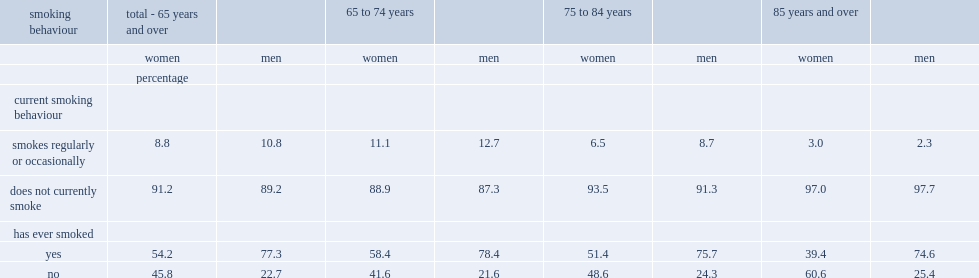What are the percentages of women and men aged 65 and over reported smoking currently, either regularly or occasionally. 8.8 10.8. Which is less likely to have ever smoked in their lifetime,senior women or senior men. Women. What are the percentages of women aged 85 and over and women aged 65 to 74 reported being current smokers. 3.0 11.1. What's the percentage of women aged 65 to 74 had smoked in their lifetime. 58.4. 